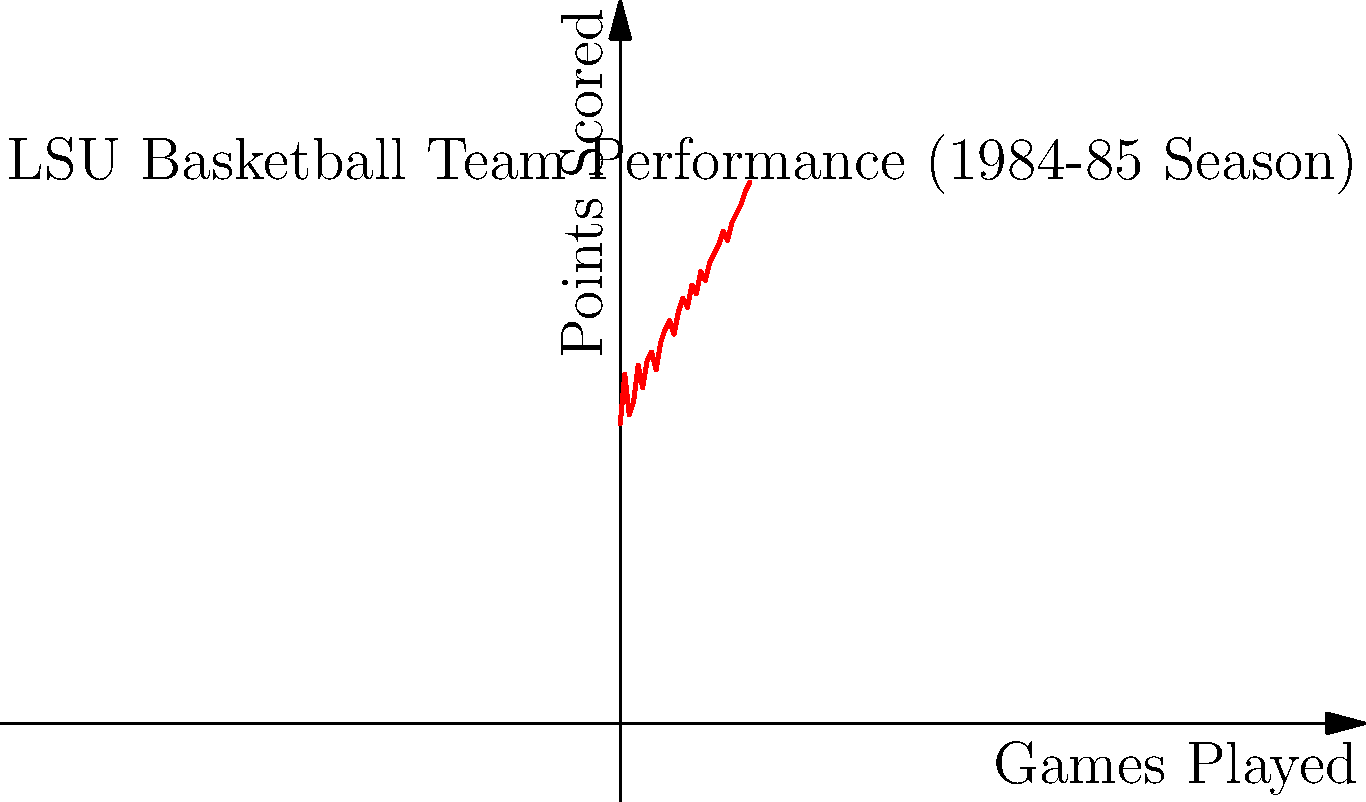The graph shows LSU's basketball team performance during the 1984-85 season. Using polynomial regression, which degree polynomial would best model this data, and what does it suggest about the team's improvement over the season? To determine the best polynomial degree for modeling this data, we need to consider the following steps:

1. Observe the overall trend: The data shows a generally increasing trend, but with some fluctuations.

2. Consider polynomial degrees:
   - Linear (1st degree): May capture the overall trend but miss local variations.
   - Quadratic (2nd degree): Could capture some curvature but might not be flexible enough.
   - Cubic (3rd degree): Offers more flexibility to capture both the overall trend and local variations.
   - Higher degrees: May overfit the data, capturing noise rather than the true trend.

3. Analyze the pattern:
   The team's performance shows a gradual improvement over time, with some ups and downs. This suggests a polynomial of degree 2 or 3 might be appropriate.

4. Consider the context:
   As a freshman during the 1984-85 season, you would have observed the team's development. A cubic polynomial (3rd degree) would likely best capture the team's improvement pattern, showing:
   - Initial adjustment period (slight curve at the start)
   - Steady improvement in the middle of the season
   - Potential plateau or accelerated improvement towards the end

5. Interpretation:
   A cubic polynomial would suggest that the team had an initial adjustment period, followed by consistent improvement, and potentially a strong finish to the season. This aligns with the typical pattern of a team developing over a season, especially with new players (like freshmen) integrating into the team.

Therefore, a 3rd-degree (cubic) polynomial would likely provide the best balance between capturing the overall trend and local variations without overfitting the data.
Answer: 3rd-degree polynomial; suggests initial adjustment, steady improvement, and strong finish. 